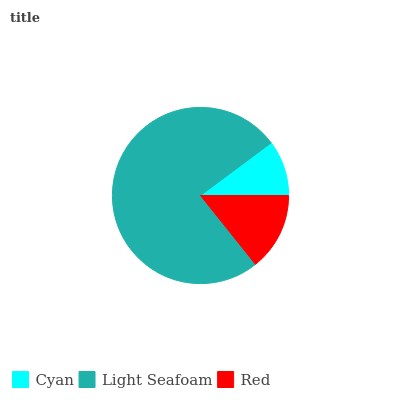Is Cyan the minimum?
Answer yes or no. Yes. Is Light Seafoam the maximum?
Answer yes or no. Yes. Is Red the minimum?
Answer yes or no. No. Is Red the maximum?
Answer yes or no. No. Is Light Seafoam greater than Red?
Answer yes or no. Yes. Is Red less than Light Seafoam?
Answer yes or no. Yes. Is Red greater than Light Seafoam?
Answer yes or no. No. Is Light Seafoam less than Red?
Answer yes or no. No. Is Red the high median?
Answer yes or no. Yes. Is Red the low median?
Answer yes or no. Yes. Is Cyan the high median?
Answer yes or no. No. Is Light Seafoam the low median?
Answer yes or no. No. 